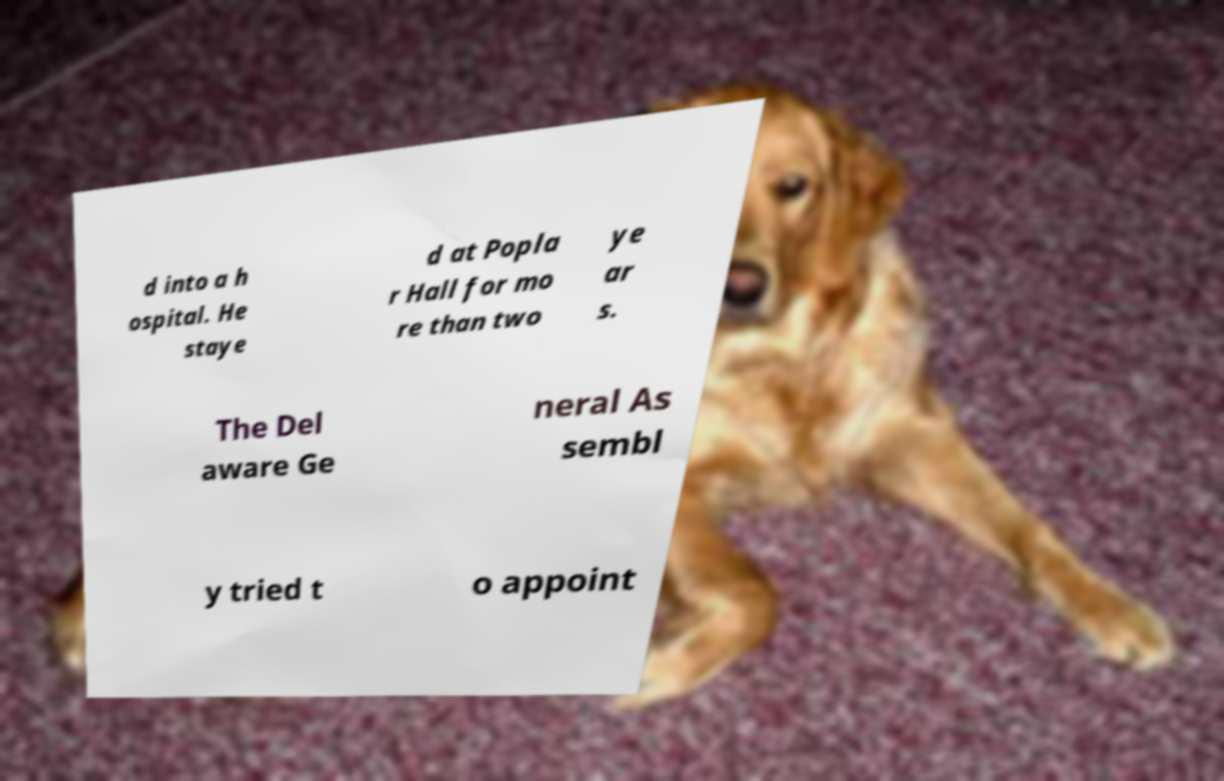Please read and relay the text visible in this image. What does it say? d into a h ospital. He staye d at Popla r Hall for mo re than two ye ar s. The Del aware Ge neral As sembl y tried t o appoint 